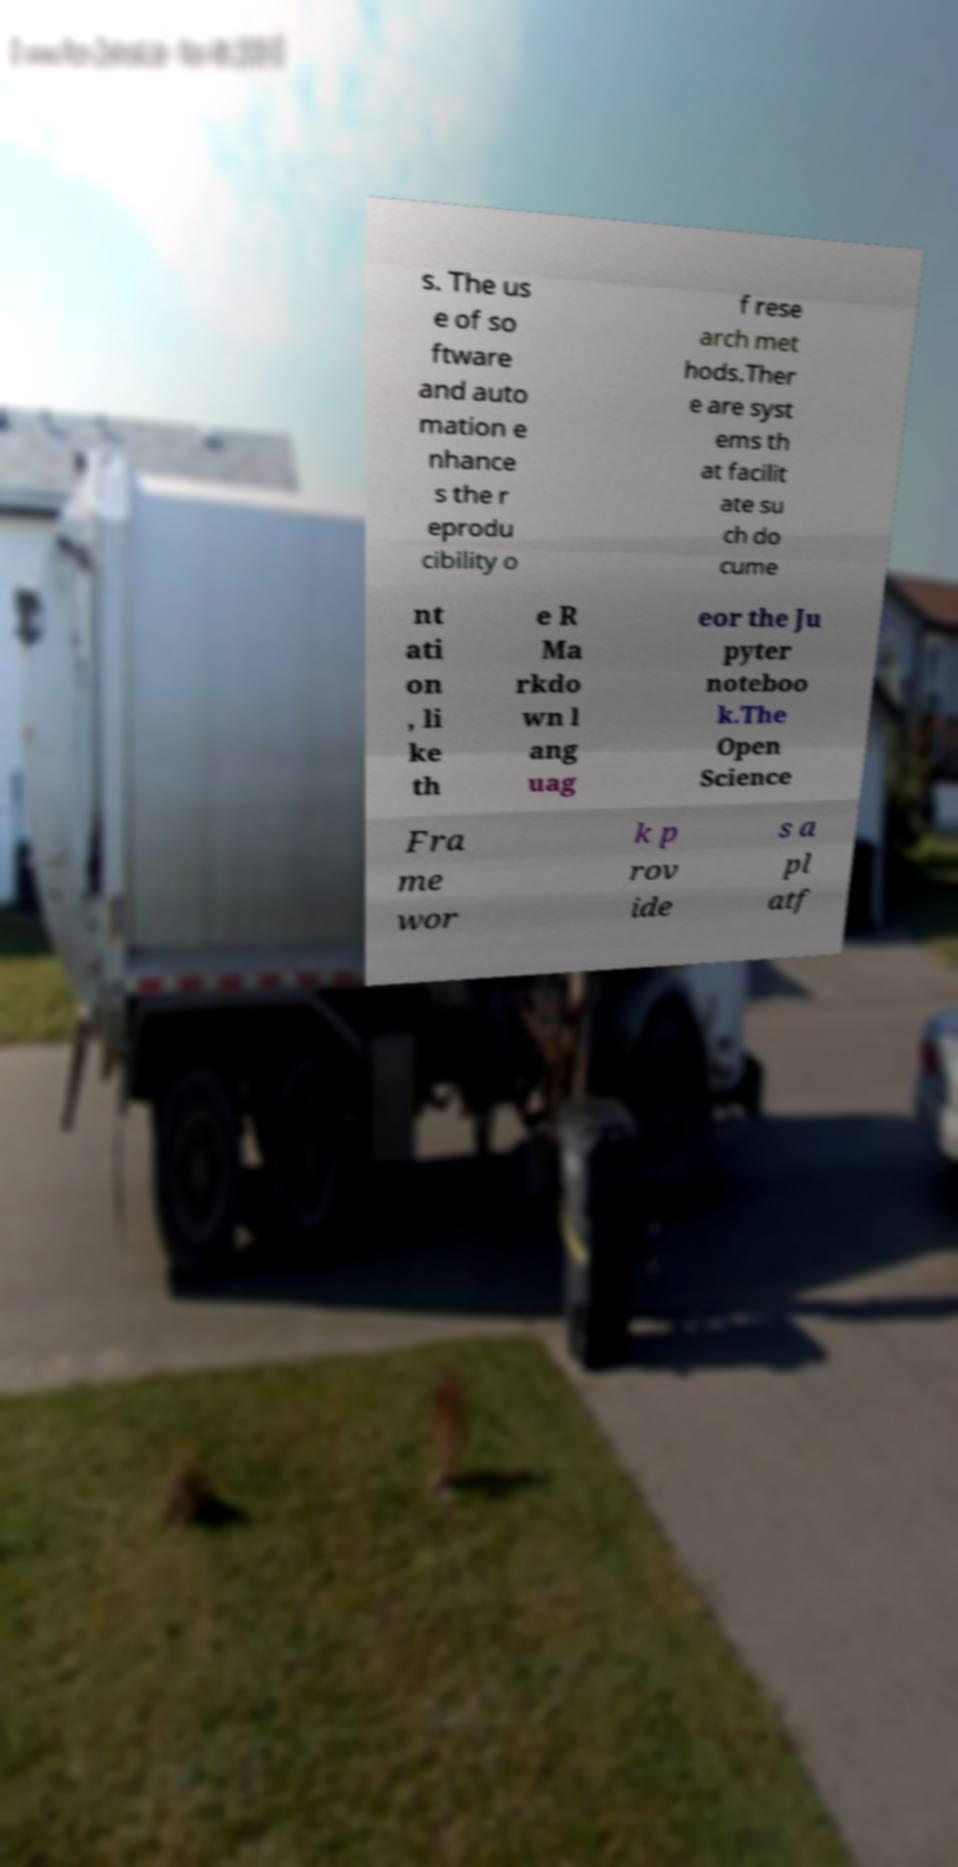Could you assist in decoding the text presented in this image and type it out clearly? s. The us e of so ftware and auto mation e nhance s the r eprodu cibility o f rese arch met hods.Ther e are syst ems th at facilit ate su ch do cume nt ati on , li ke th e R Ma rkdo wn l ang uag eor the Ju pyter noteboo k.The Open Science Fra me wor k p rov ide s a pl atf 